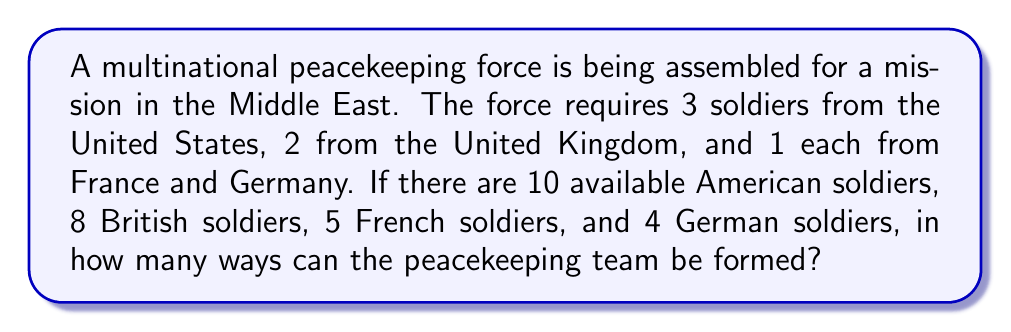Can you answer this question? To solve this problem, we need to use the multiplication principle of counting. We'll break down the selection process for each country:

1. United States: We need to choose 3 soldiers out of 10 available. This is a combination problem, denoted as $\binom{10}{3}$.

2. United Kingdom: We need to choose 2 soldiers out of 8 available. This is denoted as $\binom{8}{2}$.

3. France: We need to choose 1 soldier out of 5 available. This is simply $\binom{5}{1}$.

4. Germany: We need to choose 1 soldier out of 4 available. This is $\binom{4}{1}$.

The total number of ways to form the team is the product of these individual selections:

$$\binom{10}{3} \times \binom{8}{2} \times \binom{5}{1} \times \binom{4}{1}$$

Now, let's calculate each combination:

1. $\binom{10}{3} = \frac{10!}{3!(10-3)!} = \frac{10!}{3!7!} = 120$

2. $\binom{8}{2} = \frac{8!}{2!(8-2)!} = \frac{8!}{2!6!} = 28$

3. $\binom{5}{1} = \frac{5!}{1!(5-1)!} = \frac{5!}{1!4!} = 5$

4. $\binom{4}{1} = \frac{4!}{1!(4-1)!} = \frac{4!}{1!3!} = 4$

Multiplying these results:

$$120 \times 28 \times 5 \times 4 = 67,200$$
Answer: 67,200 ways 